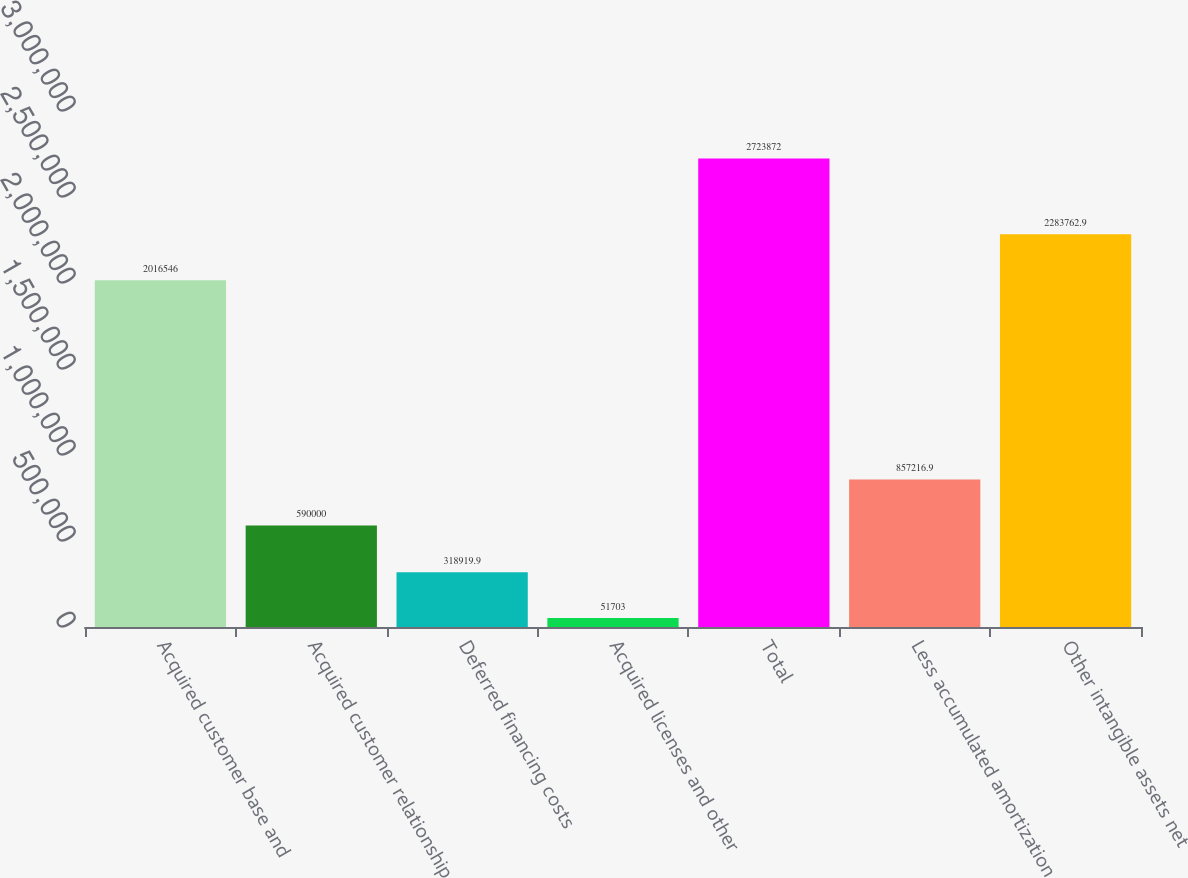Convert chart. <chart><loc_0><loc_0><loc_500><loc_500><bar_chart><fcel>Acquired customer base and<fcel>Acquired customer relationship<fcel>Deferred financing costs<fcel>Acquired licenses and other<fcel>Total<fcel>Less accumulated amortization<fcel>Other intangible assets net<nl><fcel>2.01655e+06<fcel>590000<fcel>318920<fcel>51703<fcel>2.72387e+06<fcel>857217<fcel>2.28376e+06<nl></chart> 